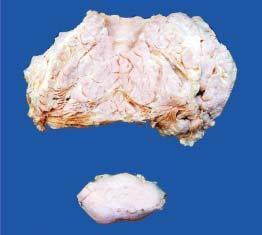what is multilobulated with increased fat while lower part of the image shows a separate encapsulated gelatinous mass?
Answer the question using a single word or phrase. Main mass 